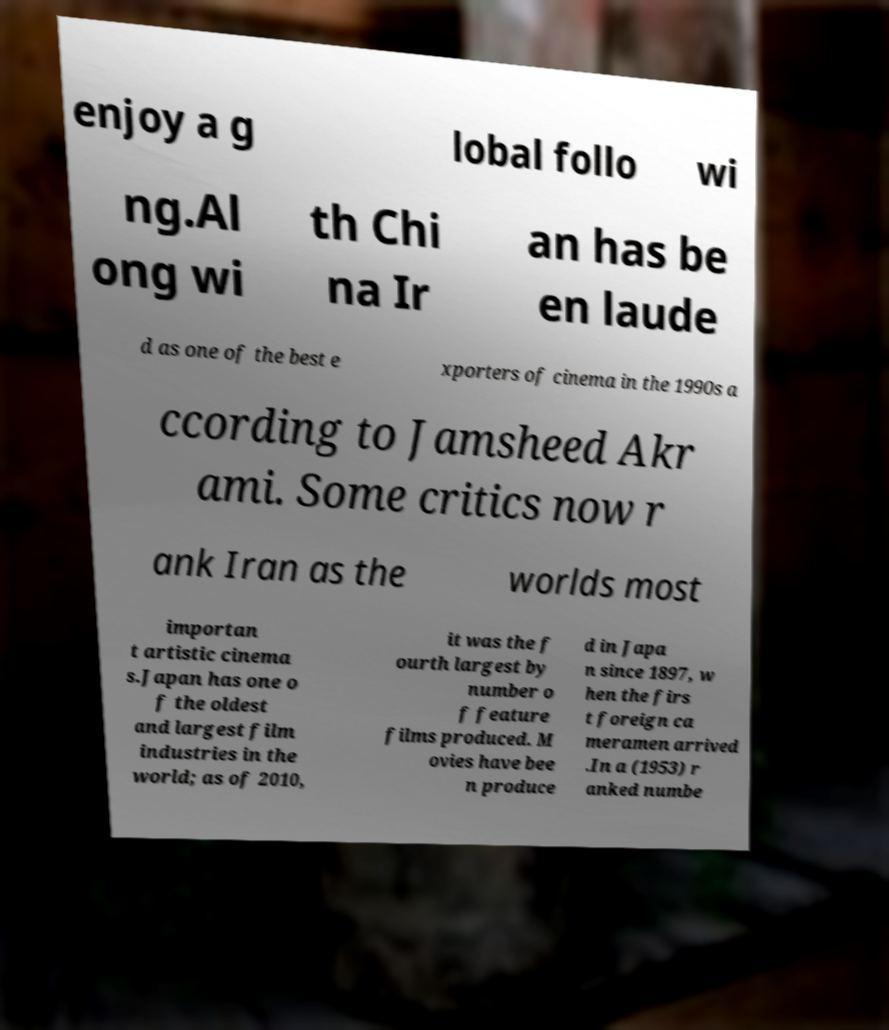Can you accurately transcribe the text from the provided image for me? enjoy a g lobal follo wi ng.Al ong wi th Chi na Ir an has be en laude d as one of the best e xporters of cinema in the 1990s a ccording to Jamsheed Akr ami. Some critics now r ank Iran as the worlds most importan t artistic cinema s.Japan has one o f the oldest and largest film industries in the world; as of 2010, it was the f ourth largest by number o f feature films produced. M ovies have bee n produce d in Japa n since 1897, w hen the firs t foreign ca meramen arrived .In a (1953) r anked numbe 